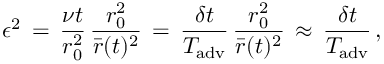<formula> <loc_0><loc_0><loc_500><loc_500>\epsilon ^ { 2 } \, = \, \frac { \nu t } { r _ { 0 } ^ { 2 } } \, \frac { r _ { 0 } ^ { 2 } } { \bar { r } ( t ) ^ { 2 } } \, = \, \frac { \delta t } { T _ { a d v } } \, \frac { r _ { 0 } ^ { 2 } } { \bar { r } ( t ) ^ { 2 } } \, \approx \, \frac { \delta t } { T _ { a d v } } \, ,</formula> 